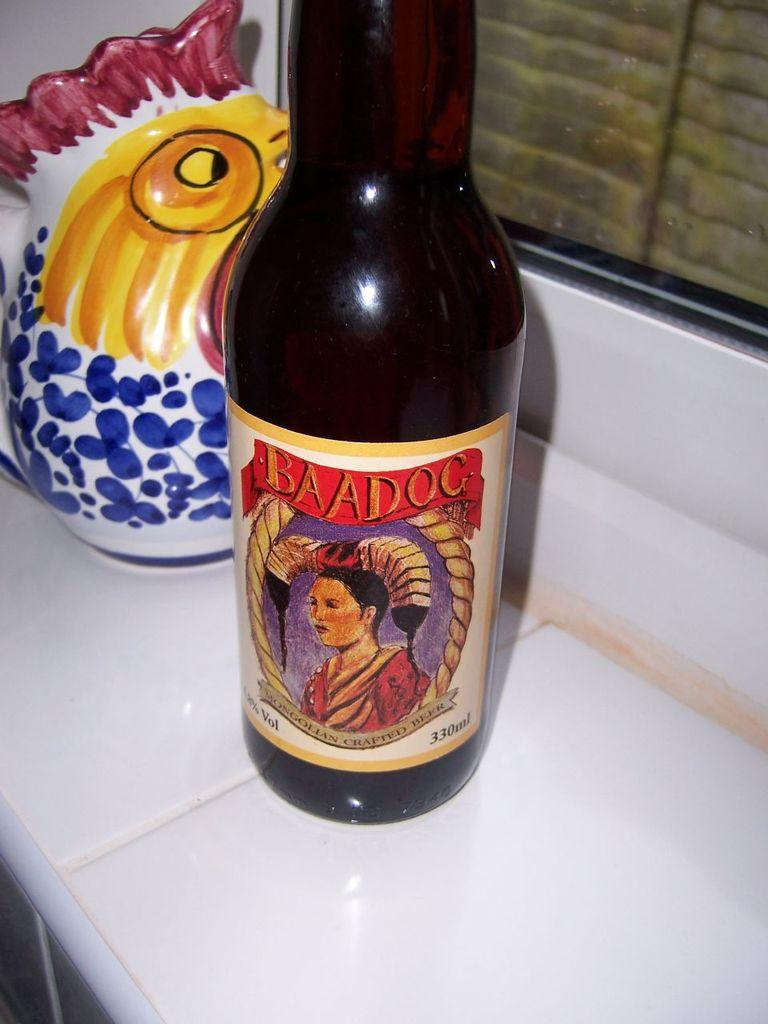<image>
Provide a brief description of the given image. Baadog Beer bottle with a label of a woman that contains 330 ML. 